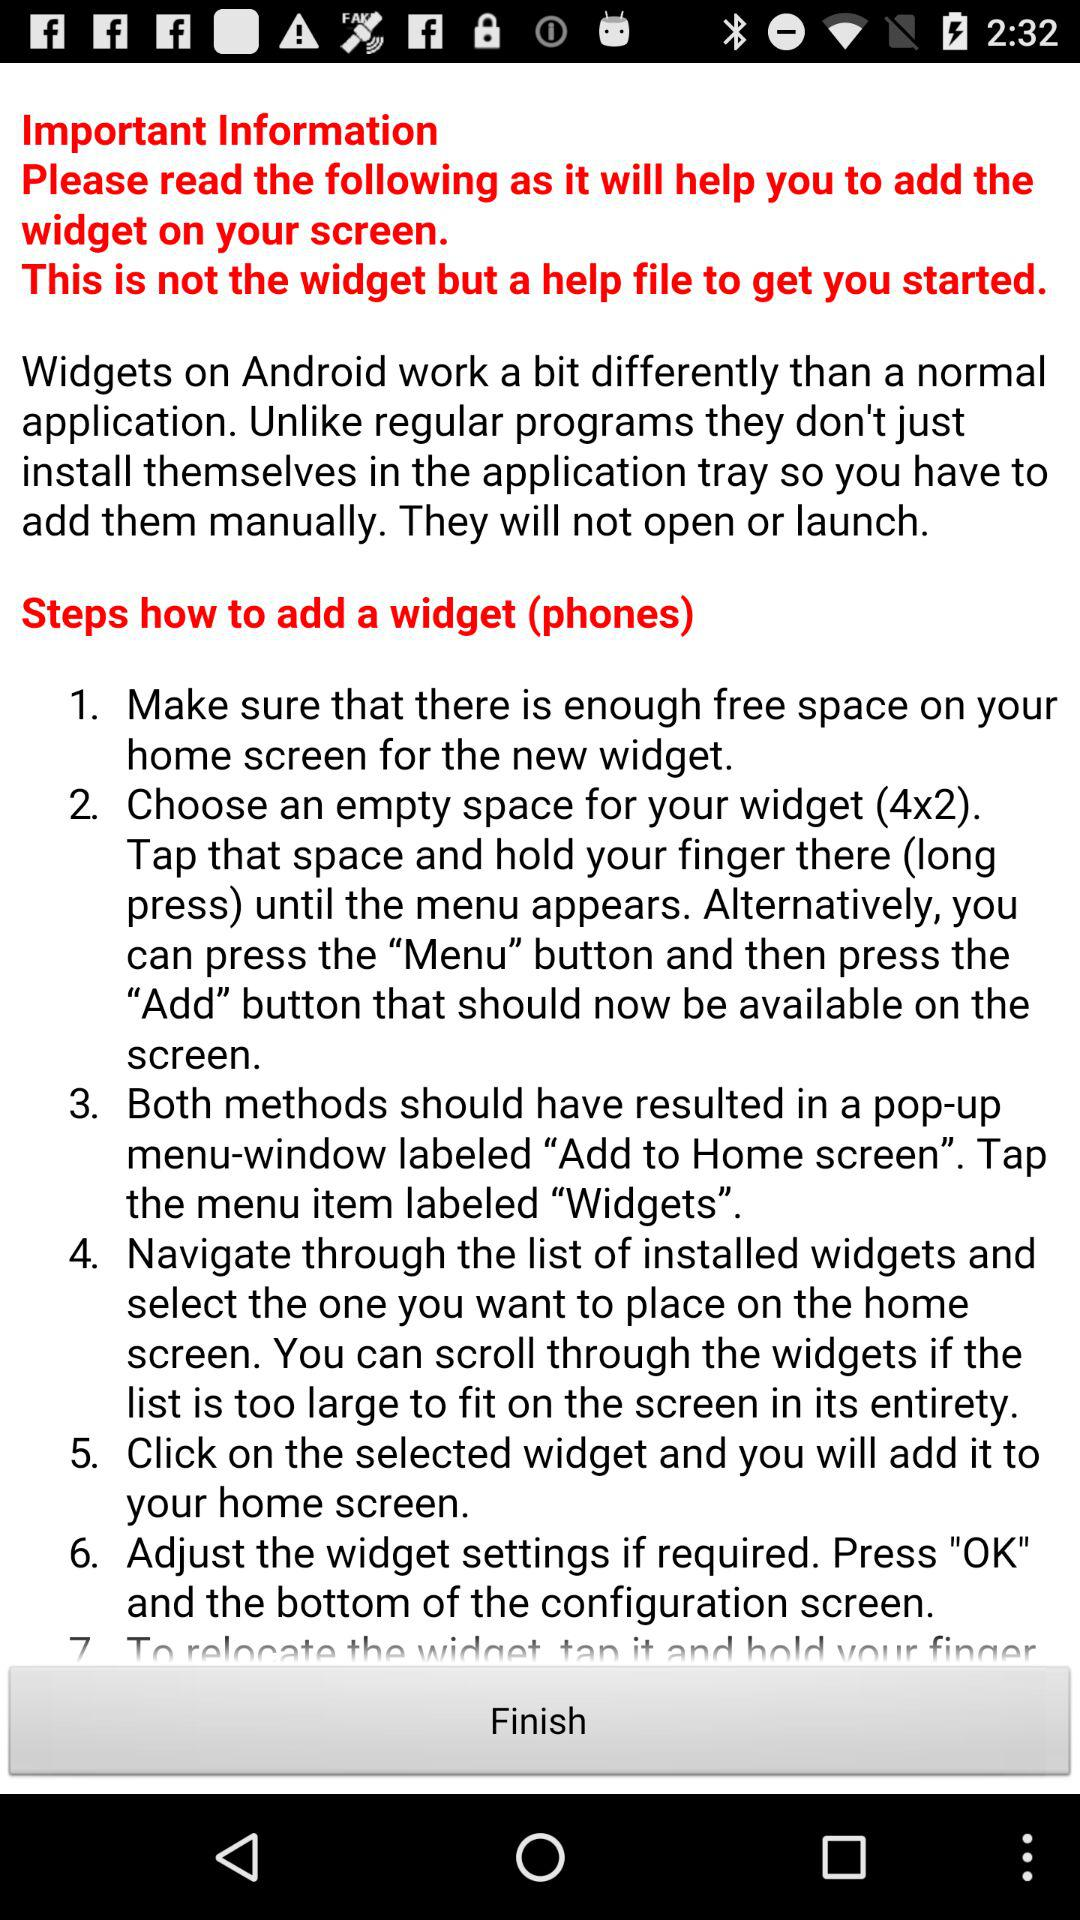How many different ways are there to add a widget?
Answer the question using a single word or phrase. 2 